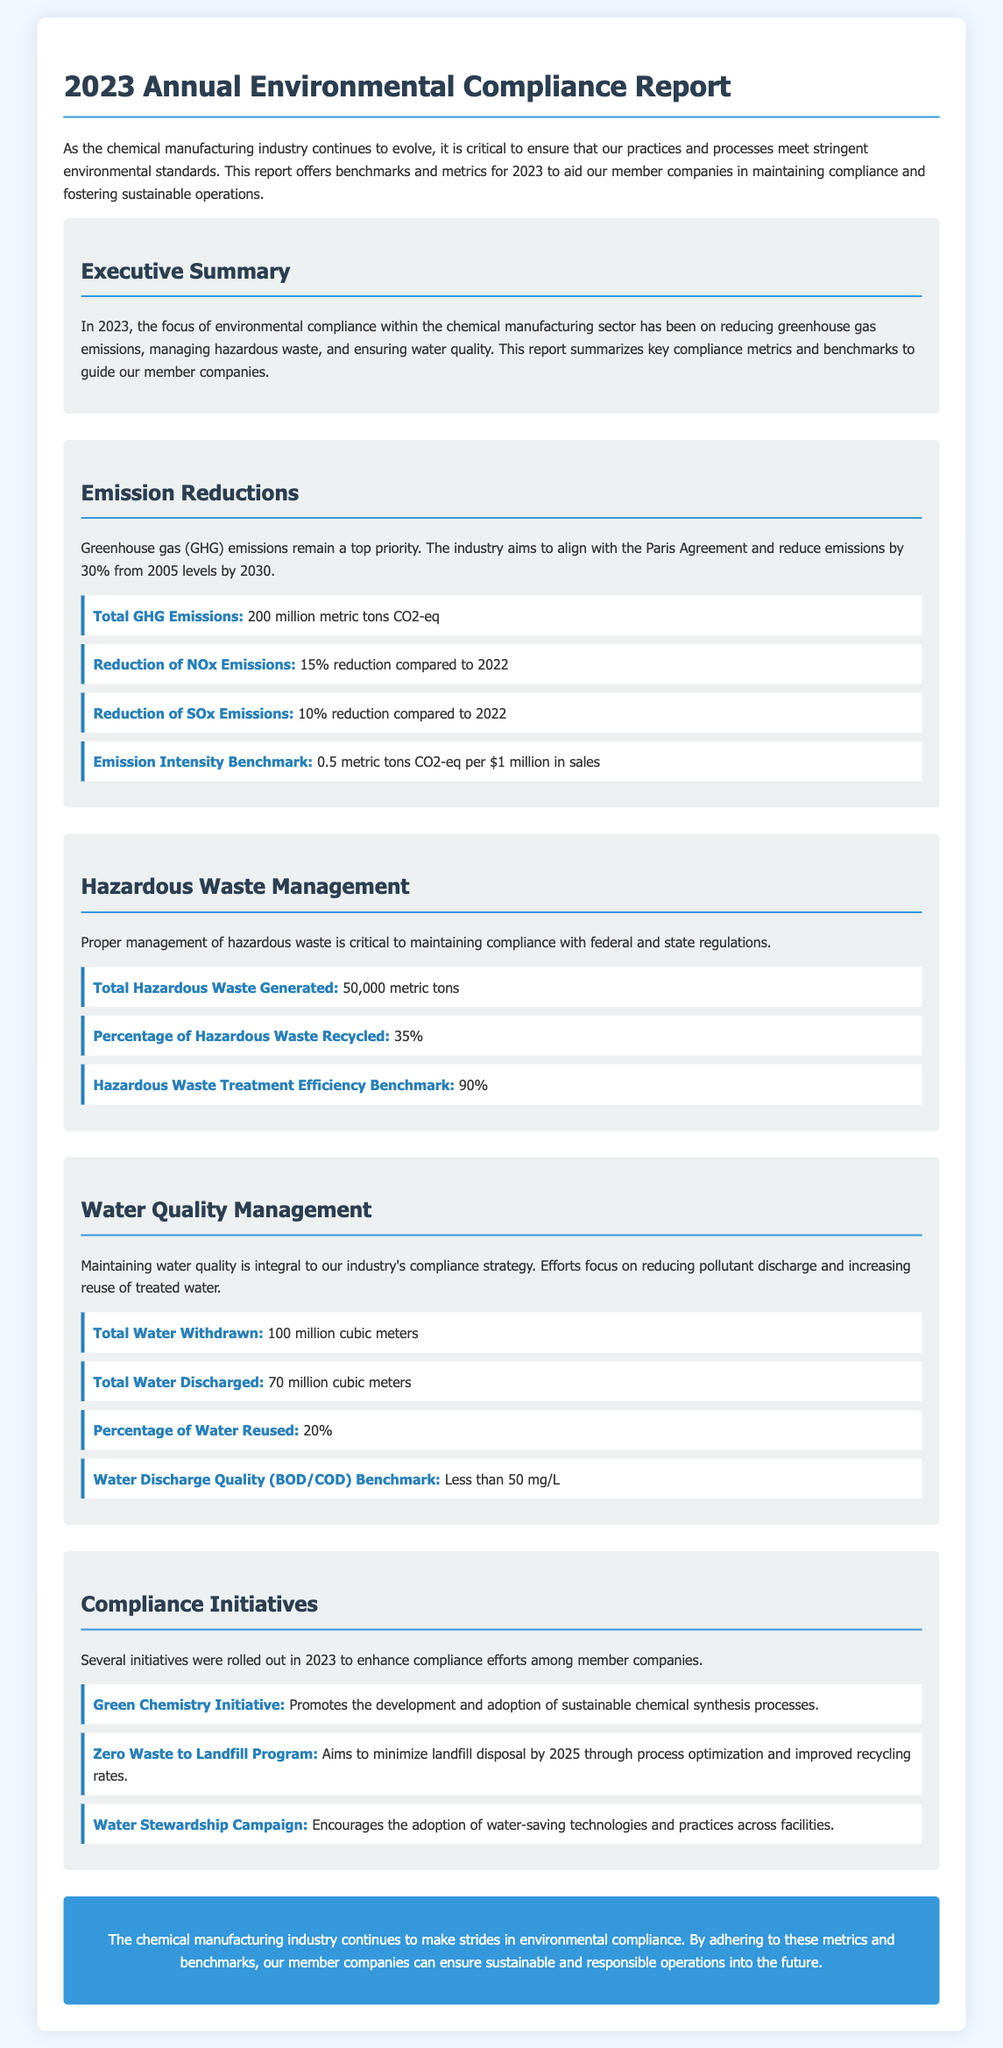what is the total GHG emissions? The total GHG emissions reported are for the year 2023, listed in metric tons CO2-eq.
Answer: 200 million metric tons CO2-eq what is the percentage of hazardous waste recycled? This figure provides insight into the efficiency of hazardous waste management practices in the industry for 2023.
Answer: 35% what is the target reduction of GHG emissions by 2030? This target aligns with global efforts for climate change mitigation described in the document.
Answer: 30% what is the emission intensity benchmark? This benchmark is a standard measure for evaluating emissions relative to industry sales performance.
Answer: 0.5 metric tons CO2-eq per $1 million in sales what is the total amount of hazardous waste generated? This metric provides a quantifiable figure on hazardous materials produced by the chemical manufacturing sector in 2023.
Answer: 50,000 metric tons what does the Green Chemistry Initiative aim to promote? This initiative is one of the compliance programs established to support sustainable practices within the industry.
Answer: Development and adoption of sustainable chemical synthesis processes how many million cubic meters of water were discharged? This figure illustrates the quantity of water released into the environment from the chemical manufacturing processes in 2023.
Answer: 70 million cubic meters what is the water discharge quality benchmark? This benchmark serves as a standard for evaluating the environmental impact of water discharged by facilities.
Answer: Less than 50 mg/L what is the percentage of water reused? This statistic indicates the effectiveness of water management strategies implemented in 2023.
Answer: 20% 